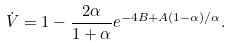Convert formula to latex. <formula><loc_0><loc_0><loc_500><loc_500>\dot { V } = 1 - \frac { 2 \alpha } { 1 + \alpha } e ^ { - 4 B + A ( 1 - \alpha ) / \alpha } .</formula> 